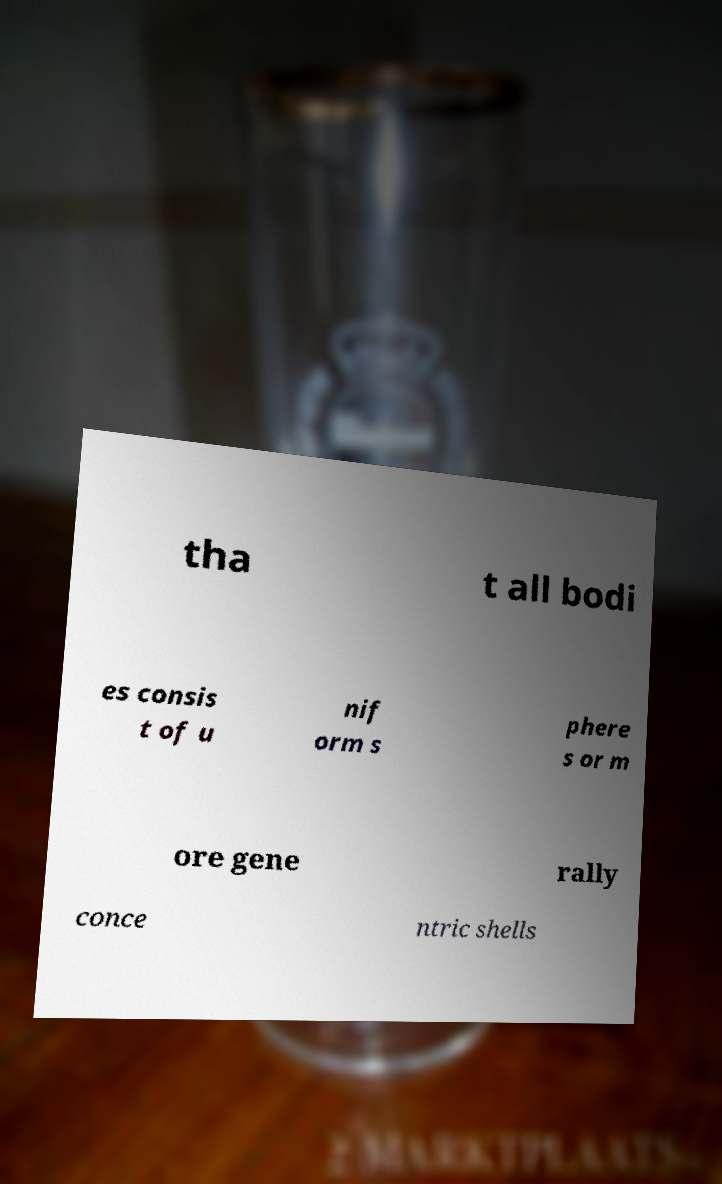I need the written content from this picture converted into text. Can you do that? tha t all bodi es consis t of u nif orm s phere s or m ore gene rally conce ntric shells 